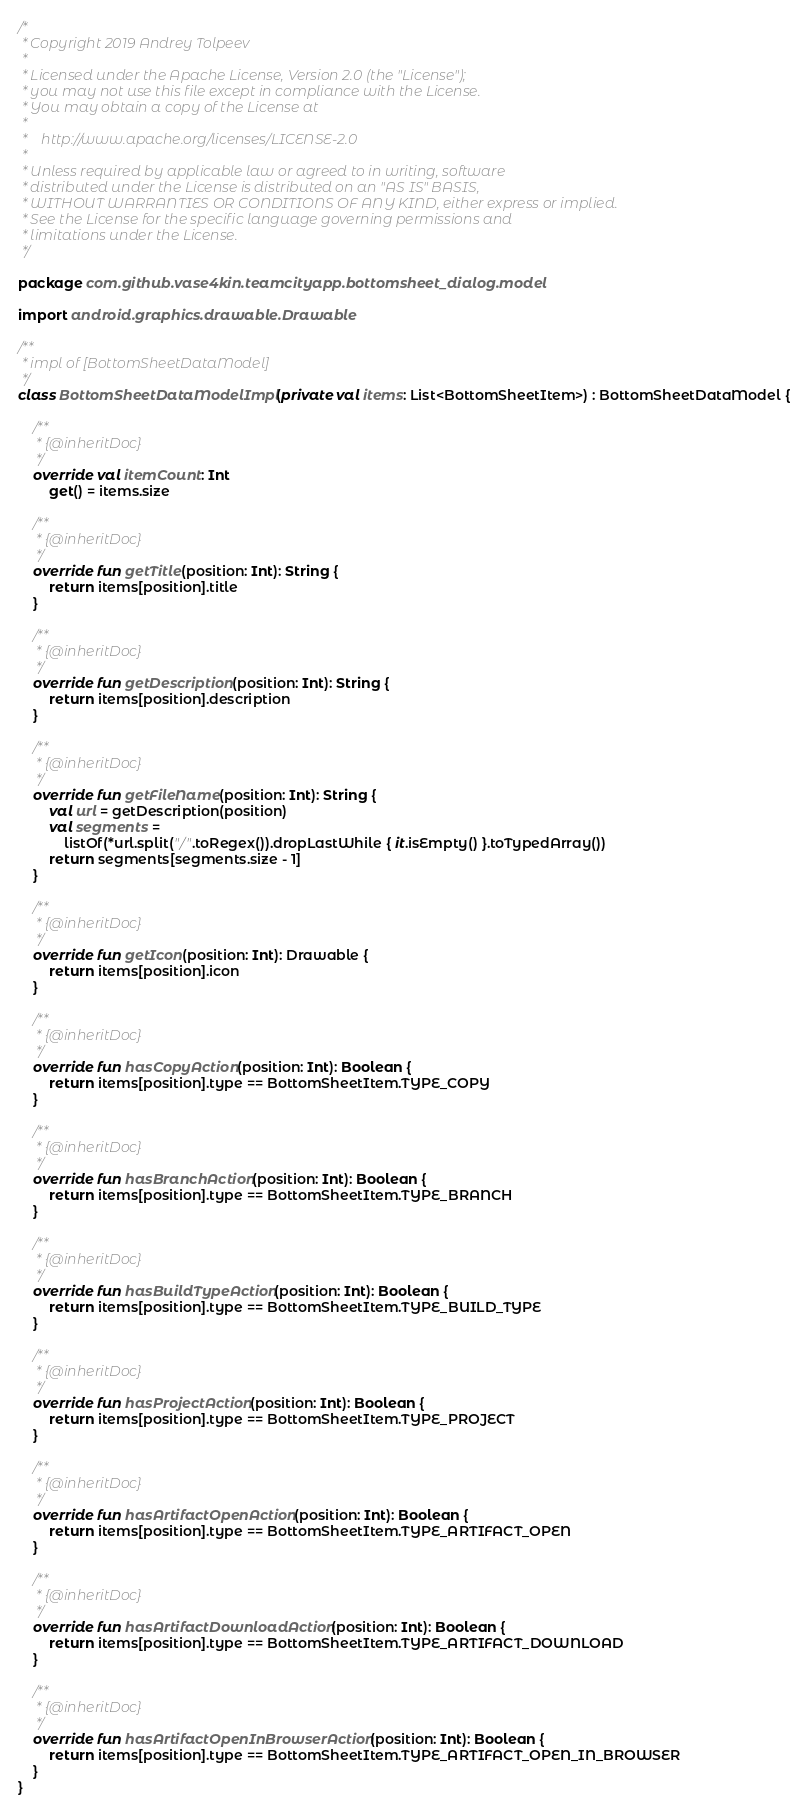Convert code to text. <code><loc_0><loc_0><loc_500><loc_500><_Kotlin_>/*
 * Copyright 2019 Andrey Tolpeev
 *
 * Licensed under the Apache License, Version 2.0 (the "License");
 * you may not use this file except in compliance with the License.
 * You may obtain a copy of the License at
 *
 *    http://www.apache.org/licenses/LICENSE-2.0
 *
 * Unless required by applicable law or agreed to in writing, software
 * distributed under the License is distributed on an "AS IS" BASIS,
 * WITHOUT WARRANTIES OR CONDITIONS OF ANY KIND, either express or implied.
 * See the License for the specific language governing permissions and
 * limitations under the License.
 */

package com.github.vase4kin.teamcityapp.bottomsheet_dialog.model

import android.graphics.drawable.Drawable

/**
 * impl of [BottomSheetDataModel]
 */
class BottomSheetDataModelImpl(private val items: List<BottomSheetItem>) : BottomSheetDataModel {

    /**
     * {@inheritDoc}
     */
    override val itemCount: Int
        get() = items.size

    /**
     * {@inheritDoc}
     */
    override fun getTitle(position: Int): String {
        return items[position].title
    }

    /**
     * {@inheritDoc}
     */
    override fun getDescription(position: Int): String {
        return items[position].description
    }

    /**
     * {@inheritDoc}
     */
    override fun getFileName(position: Int): String {
        val url = getDescription(position)
        val segments =
            listOf(*url.split("/".toRegex()).dropLastWhile { it.isEmpty() }.toTypedArray())
        return segments[segments.size - 1]
    }

    /**
     * {@inheritDoc}
     */
    override fun getIcon(position: Int): Drawable {
        return items[position].icon
    }

    /**
     * {@inheritDoc}
     */
    override fun hasCopyAction(position: Int): Boolean {
        return items[position].type == BottomSheetItem.TYPE_COPY
    }

    /**
     * {@inheritDoc}
     */
    override fun hasBranchAction(position: Int): Boolean {
        return items[position].type == BottomSheetItem.TYPE_BRANCH
    }

    /**
     * {@inheritDoc}
     */
    override fun hasBuildTypeAction(position: Int): Boolean {
        return items[position].type == BottomSheetItem.TYPE_BUILD_TYPE
    }

    /**
     * {@inheritDoc}
     */
    override fun hasProjectAction(position: Int): Boolean {
        return items[position].type == BottomSheetItem.TYPE_PROJECT
    }

    /**
     * {@inheritDoc}
     */
    override fun hasArtifactOpenAction(position: Int): Boolean {
        return items[position].type == BottomSheetItem.TYPE_ARTIFACT_OPEN
    }

    /**
     * {@inheritDoc}
     */
    override fun hasArtifactDownloadAction(position: Int): Boolean {
        return items[position].type == BottomSheetItem.TYPE_ARTIFACT_DOWNLOAD
    }

    /**
     * {@inheritDoc}
     */
    override fun hasArtifactOpenInBrowserAction(position: Int): Boolean {
        return items[position].type == BottomSheetItem.TYPE_ARTIFACT_OPEN_IN_BROWSER
    }
}
</code> 